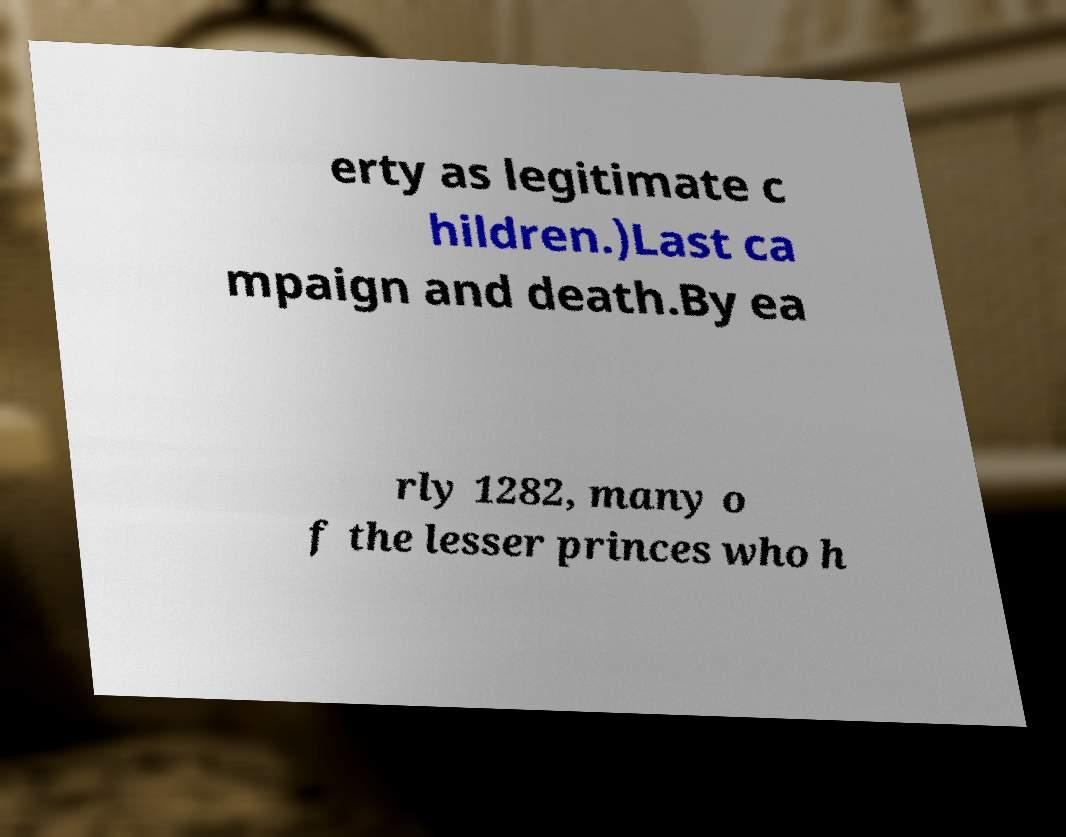Please read and relay the text visible in this image. What does it say? erty as legitimate c hildren.)Last ca mpaign and death.By ea rly 1282, many o f the lesser princes who h 